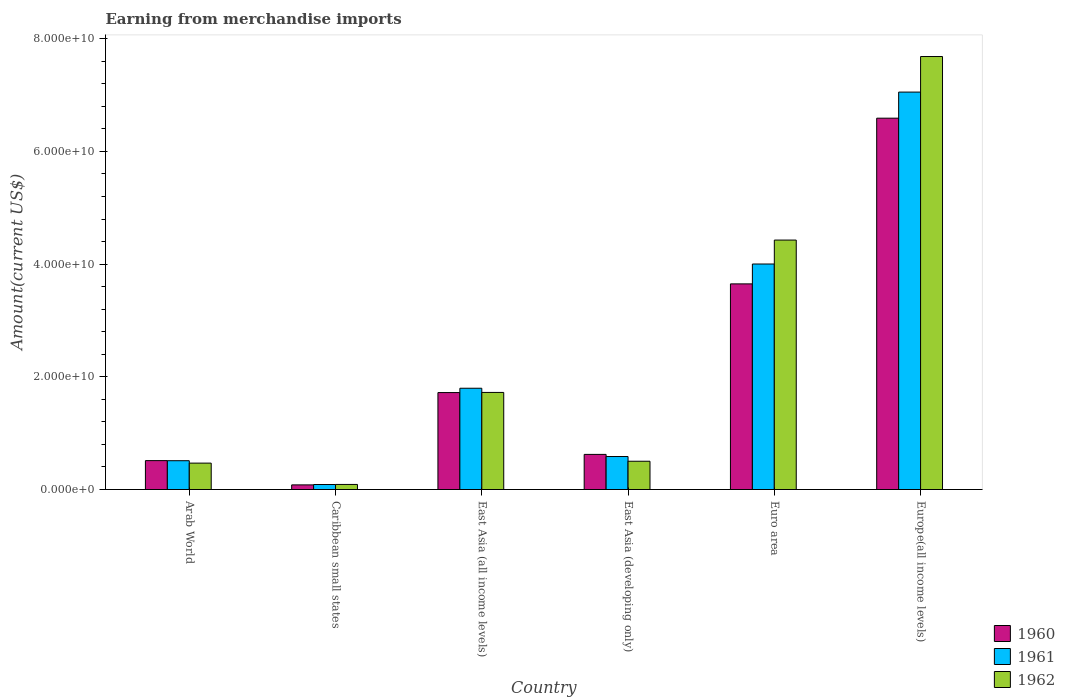How many groups of bars are there?
Offer a terse response. 6. Are the number of bars per tick equal to the number of legend labels?
Provide a short and direct response. Yes. How many bars are there on the 5th tick from the right?
Provide a short and direct response. 3. What is the label of the 1st group of bars from the left?
Offer a very short reply. Arab World. What is the amount earned from merchandise imports in 1961 in Arab World?
Offer a very short reply. 5.11e+09. Across all countries, what is the maximum amount earned from merchandise imports in 1962?
Provide a succinct answer. 7.68e+1. Across all countries, what is the minimum amount earned from merchandise imports in 1962?
Offer a terse response. 9.01e+08. In which country was the amount earned from merchandise imports in 1962 maximum?
Your response must be concise. Europe(all income levels). In which country was the amount earned from merchandise imports in 1960 minimum?
Provide a succinct answer. Caribbean small states. What is the total amount earned from merchandise imports in 1960 in the graph?
Make the answer very short. 1.32e+11. What is the difference between the amount earned from merchandise imports in 1962 in East Asia (developing only) and that in Euro area?
Your answer should be very brief. -3.93e+1. What is the difference between the amount earned from merchandise imports in 1962 in Arab World and the amount earned from merchandise imports in 1960 in East Asia (developing only)?
Your response must be concise. -1.55e+09. What is the average amount earned from merchandise imports in 1961 per country?
Provide a short and direct response. 2.34e+1. What is the difference between the amount earned from merchandise imports of/in 1961 and amount earned from merchandise imports of/in 1960 in East Asia (all income levels)?
Offer a very short reply. 7.70e+08. In how many countries, is the amount earned from merchandise imports in 1962 greater than 8000000000 US$?
Your answer should be very brief. 3. What is the ratio of the amount earned from merchandise imports in 1960 in Caribbean small states to that in East Asia (all income levels)?
Make the answer very short. 0.05. Is the amount earned from merchandise imports in 1961 in East Asia (all income levels) less than that in Europe(all income levels)?
Offer a terse response. Yes. Is the difference between the amount earned from merchandise imports in 1961 in East Asia (all income levels) and Europe(all income levels) greater than the difference between the amount earned from merchandise imports in 1960 in East Asia (all income levels) and Europe(all income levels)?
Keep it short and to the point. No. What is the difference between the highest and the second highest amount earned from merchandise imports in 1961?
Your answer should be very brief. 5.26e+1. What is the difference between the highest and the lowest amount earned from merchandise imports in 1961?
Your answer should be compact. 6.96e+1. In how many countries, is the amount earned from merchandise imports in 1962 greater than the average amount earned from merchandise imports in 1962 taken over all countries?
Provide a succinct answer. 2. Is the sum of the amount earned from merchandise imports in 1960 in East Asia (all income levels) and Europe(all income levels) greater than the maximum amount earned from merchandise imports in 1961 across all countries?
Offer a very short reply. Yes. What does the 2nd bar from the left in Arab World represents?
Your answer should be compact. 1961. What does the 2nd bar from the right in East Asia (all income levels) represents?
Your response must be concise. 1961. Is it the case that in every country, the sum of the amount earned from merchandise imports in 1961 and amount earned from merchandise imports in 1960 is greater than the amount earned from merchandise imports in 1962?
Provide a short and direct response. Yes. How many bars are there?
Offer a very short reply. 18. How many countries are there in the graph?
Ensure brevity in your answer.  6. Does the graph contain any zero values?
Give a very brief answer. No. Does the graph contain grids?
Offer a terse response. No. Where does the legend appear in the graph?
Offer a terse response. Bottom right. How many legend labels are there?
Offer a terse response. 3. What is the title of the graph?
Your answer should be very brief. Earning from merchandise imports. Does "1968" appear as one of the legend labels in the graph?
Your answer should be very brief. No. What is the label or title of the X-axis?
Make the answer very short. Country. What is the label or title of the Y-axis?
Offer a terse response. Amount(current US$). What is the Amount(current US$) in 1960 in Arab World?
Your answer should be very brief. 5.13e+09. What is the Amount(current US$) in 1961 in Arab World?
Keep it short and to the point. 5.11e+09. What is the Amount(current US$) in 1962 in Arab World?
Make the answer very short. 4.69e+09. What is the Amount(current US$) of 1960 in Caribbean small states?
Your response must be concise. 8.24e+08. What is the Amount(current US$) of 1961 in Caribbean small states?
Provide a short and direct response. 8.89e+08. What is the Amount(current US$) in 1962 in Caribbean small states?
Keep it short and to the point. 9.01e+08. What is the Amount(current US$) in 1960 in East Asia (all income levels)?
Your answer should be very brief. 1.72e+1. What is the Amount(current US$) in 1961 in East Asia (all income levels)?
Give a very brief answer. 1.80e+1. What is the Amount(current US$) of 1962 in East Asia (all income levels)?
Offer a terse response. 1.72e+1. What is the Amount(current US$) of 1960 in East Asia (developing only)?
Offer a terse response. 6.23e+09. What is the Amount(current US$) in 1961 in East Asia (developing only)?
Your answer should be compact. 5.86e+09. What is the Amount(current US$) in 1962 in East Asia (developing only)?
Ensure brevity in your answer.  5.02e+09. What is the Amount(current US$) of 1960 in Euro area?
Your answer should be very brief. 3.65e+1. What is the Amount(current US$) in 1961 in Euro area?
Provide a short and direct response. 4.00e+1. What is the Amount(current US$) in 1962 in Euro area?
Provide a short and direct response. 4.43e+1. What is the Amount(current US$) in 1960 in Europe(all income levels)?
Offer a very short reply. 6.59e+1. What is the Amount(current US$) of 1961 in Europe(all income levels)?
Ensure brevity in your answer.  7.05e+1. What is the Amount(current US$) in 1962 in Europe(all income levels)?
Your answer should be very brief. 7.68e+1. Across all countries, what is the maximum Amount(current US$) of 1960?
Give a very brief answer. 6.59e+1. Across all countries, what is the maximum Amount(current US$) in 1961?
Make the answer very short. 7.05e+1. Across all countries, what is the maximum Amount(current US$) in 1962?
Your answer should be compact. 7.68e+1. Across all countries, what is the minimum Amount(current US$) of 1960?
Your response must be concise. 8.24e+08. Across all countries, what is the minimum Amount(current US$) of 1961?
Provide a succinct answer. 8.89e+08. Across all countries, what is the minimum Amount(current US$) of 1962?
Provide a short and direct response. 9.01e+08. What is the total Amount(current US$) in 1960 in the graph?
Your answer should be very brief. 1.32e+11. What is the total Amount(current US$) in 1961 in the graph?
Offer a very short reply. 1.40e+11. What is the total Amount(current US$) of 1962 in the graph?
Provide a short and direct response. 1.49e+11. What is the difference between the Amount(current US$) of 1960 in Arab World and that in Caribbean small states?
Give a very brief answer. 4.31e+09. What is the difference between the Amount(current US$) in 1961 in Arab World and that in Caribbean small states?
Your answer should be very brief. 4.22e+09. What is the difference between the Amount(current US$) of 1962 in Arab World and that in Caribbean small states?
Your answer should be very brief. 3.78e+09. What is the difference between the Amount(current US$) in 1960 in Arab World and that in East Asia (all income levels)?
Keep it short and to the point. -1.21e+1. What is the difference between the Amount(current US$) of 1961 in Arab World and that in East Asia (all income levels)?
Offer a very short reply. -1.29e+1. What is the difference between the Amount(current US$) in 1962 in Arab World and that in East Asia (all income levels)?
Your answer should be very brief. -1.25e+1. What is the difference between the Amount(current US$) of 1960 in Arab World and that in East Asia (developing only)?
Provide a short and direct response. -1.10e+09. What is the difference between the Amount(current US$) in 1961 in Arab World and that in East Asia (developing only)?
Your answer should be very brief. -7.42e+08. What is the difference between the Amount(current US$) of 1962 in Arab World and that in East Asia (developing only)?
Offer a very short reply. -3.33e+08. What is the difference between the Amount(current US$) of 1960 in Arab World and that in Euro area?
Ensure brevity in your answer.  -3.14e+1. What is the difference between the Amount(current US$) of 1961 in Arab World and that in Euro area?
Provide a short and direct response. -3.49e+1. What is the difference between the Amount(current US$) in 1962 in Arab World and that in Euro area?
Give a very brief answer. -3.96e+1. What is the difference between the Amount(current US$) in 1960 in Arab World and that in Europe(all income levels)?
Ensure brevity in your answer.  -6.08e+1. What is the difference between the Amount(current US$) in 1961 in Arab World and that in Europe(all income levels)?
Provide a succinct answer. -6.54e+1. What is the difference between the Amount(current US$) in 1962 in Arab World and that in Europe(all income levels)?
Keep it short and to the point. -7.22e+1. What is the difference between the Amount(current US$) of 1960 in Caribbean small states and that in East Asia (all income levels)?
Offer a very short reply. -1.64e+1. What is the difference between the Amount(current US$) of 1961 in Caribbean small states and that in East Asia (all income levels)?
Offer a very short reply. -1.71e+1. What is the difference between the Amount(current US$) in 1962 in Caribbean small states and that in East Asia (all income levels)?
Keep it short and to the point. -1.63e+1. What is the difference between the Amount(current US$) in 1960 in Caribbean small states and that in East Asia (developing only)?
Ensure brevity in your answer.  -5.41e+09. What is the difference between the Amount(current US$) in 1961 in Caribbean small states and that in East Asia (developing only)?
Your response must be concise. -4.97e+09. What is the difference between the Amount(current US$) in 1962 in Caribbean small states and that in East Asia (developing only)?
Provide a succinct answer. -4.12e+09. What is the difference between the Amount(current US$) in 1960 in Caribbean small states and that in Euro area?
Provide a short and direct response. -3.57e+1. What is the difference between the Amount(current US$) of 1961 in Caribbean small states and that in Euro area?
Make the answer very short. -3.91e+1. What is the difference between the Amount(current US$) of 1962 in Caribbean small states and that in Euro area?
Give a very brief answer. -4.34e+1. What is the difference between the Amount(current US$) of 1960 in Caribbean small states and that in Europe(all income levels)?
Make the answer very short. -6.51e+1. What is the difference between the Amount(current US$) in 1961 in Caribbean small states and that in Europe(all income levels)?
Ensure brevity in your answer.  -6.96e+1. What is the difference between the Amount(current US$) in 1962 in Caribbean small states and that in Europe(all income levels)?
Provide a succinct answer. -7.59e+1. What is the difference between the Amount(current US$) of 1960 in East Asia (all income levels) and that in East Asia (developing only)?
Keep it short and to the point. 1.10e+1. What is the difference between the Amount(current US$) of 1961 in East Asia (all income levels) and that in East Asia (developing only)?
Offer a very short reply. 1.21e+1. What is the difference between the Amount(current US$) in 1962 in East Asia (all income levels) and that in East Asia (developing only)?
Provide a short and direct response. 1.22e+1. What is the difference between the Amount(current US$) in 1960 in East Asia (all income levels) and that in Euro area?
Provide a short and direct response. -1.93e+1. What is the difference between the Amount(current US$) in 1961 in East Asia (all income levels) and that in Euro area?
Provide a short and direct response. -2.20e+1. What is the difference between the Amount(current US$) of 1962 in East Asia (all income levels) and that in Euro area?
Make the answer very short. -2.70e+1. What is the difference between the Amount(current US$) in 1960 in East Asia (all income levels) and that in Europe(all income levels)?
Provide a short and direct response. -4.87e+1. What is the difference between the Amount(current US$) of 1961 in East Asia (all income levels) and that in Europe(all income levels)?
Your answer should be compact. -5.26e+1. What is the difference between the Amount(current US$) in 1962 in East Asia (all income levels) and that in Europe(all income levels)?
Your response must be concise. -5.96e+1. What is the difference between the Amount(current US$) in 1960 in East Asia (developing only) and that in Euro area?
Your answer should be compact. -3.03e+1. What is the difference between the Amount(current US$) in 1961 in East Asia (developing only) and that in Euro area?
Provide a short and direct response. -3.42e+1. What is the difference between the Amount(current US$) in 1962 in East Asia (developing only) and that in Euro area?
Provide a succinct answer. -3.93e+1. What is the difference between the Amount(current US$) in 1960 in East Asia (developing only) and that in Europe(all income levels)?
Provide a short and direct response. -5.97e+1. What is the difference between the Amount(current US$) of 1961 in East Asia (developing only) and that in Europe(all income levels)?
Your response must be concise. -6.47e+1. What is the difference between the Amount(current US$) of 1962 in East Asia (developing only) and that in Europe(all income levels)?
Provide a succinct answer. -7.18e+1. What is the difference between the Amount(current US$) of 1960 in Euro area and that in Europe(all income levels)?
Keep it short and to the point. -2.94e+1. What is the difference between the Amount(current US$) in 1961 in Euro area and that in Europe(all income levels)?
Provide a short and direct response. -3.05e+1. What is the difference between the Amount(current US$) in 1962 in Euro area and that in Europe(all income levels)?
Provide a short and direct response. -3.26e+1. What is the difference between the Amount(current US$) in 1960 in Arab World and the Amount(current US$) in 1961 in Caribbean small states?
Offer a terse response. 4.24e+09. What is the difference between the Amount(current US$) in 1960 in Arab World and the Amount(current US$) in 1962 in Caribbean small states?
Keep it short and to the point. 4.23e+09. What is the difference between the Amount(current US$) of 1961 in Arab World and the Amount(current US$) of 1962 in Caribbean small states?
Your answer should be compact. 4.21e+09. What is the difference between the Amount(current US$) in 1960 in Arab World and the Amount(current US$) in 1961 in East Asia (all income levels)?
Offer a very short reply. -1.28e+1. What is the difference between the Amount(current US$) of 1960 in Arab World and the Amount(current US$) of 1962 in East Asia (all income levels)?
Ensure brevity in your answer.  -1.21e+1. What is the difference between the Amount(current US$) in 1961 in Arab World and the Amount(current US$) in 1962 in East Asia (all income levels)?
Your answer should be very brief. -1.21e+1. What is the difference between the Amount(current US$) in 1960 in Arab World and the Amount(current US$) in 1961 in East Asia (developing only)?
Offer a very short reply. -7.25e+08. What is the difference between the Amount(current US$) in 1960 in Arab World and the Amount(current US$) in 1962 in East Asia (developing only)?
Ensure brevity in your answer.  1.13e+08. What is the difference between the Amount(current US$) of 1961 in Arab World and the Amount(current US$) of 1962 in East Asia (developing only)?
Provide a short and direct response. 9.57e+07. What is the difference between the Amount(current US$) in 1960 in Arab World and the Amount(current US$) in 1961 in Euro area?
Provide a short and direct response. -3.49e+1. What is the difference between the Amount(current US$) of 1960 in Arab World and the Amount(current US$) of 1962 in Euro area?
Offer a very short reply. -3.91e+1. What is the difference between the Amount(current US$) of 1961 in Arab World and the Amount(current US$) of 1962 in Euro area?
Your answer should be very brief. -3.92e+1. What is the difference between the Amount(current US$) in 1960 in Arab World and the Amount(current US$) in 1961 in Europe(all income levels)?
Your response must be concise. -6.54e+1. What is the difference between the Amount(current US$) of 1960 in Arab World and the Amount(current US$) of 1962 in Europe(all income levels)?
Give a very brief answer. -7.17e+1. What is the difference between the Amount(current US$) in 1961 in Arab World and the Amount(current US$) in 1962 in Europe(all income levels)?
Offer a terse response. -7.17e+1. What is the difference between the Amount(current US$) in 1960 in Caribbean small states and the Amount(current US$) in 1961 in East Asia (all income levels)?
Your answer should be very brief. -1.72e+1. What is the difference between the Amount(current US$) of 1960 in Caribbean small states and the Amount(current US$) of 1962 in East Asia (all income levels)?
Your response must be concise. -1.64e+1. What is the difference between the Amount(current US$) of 1961 in Caribbean small states and the Amount(current US$) of 1962 in East Asia (all income levels)?
Ensure brevity in your answer.  -1.63e+1. What is the difference between the Amount(current US$) of 1960 in Caribbean small states and the Amount(current US$) of 1961 in East Asia (developing only)?
Provide a succinct answer. -5.03e+09. What is the difference between the Amount(current US$) in 1960 in Caribbean small states and the Amount(current US$) in 1962 in East Asia (developing only)?
Ensure brevity in your answer.  -4.19e+09. What is the difference between the Amount(current US$) in 1961 in Caribbean small states and the Amount(current US$) in 1962 in East Asia (developing only)?
Offer a terse response. -4.13e+09. What is the difference between the Amount(current US$) in 1960 in Caribbean small states and the Amount(current US$) in 1961 in Euro area?
Give a very brief answer. -3.92e+1. What is the difference between the Amount(current US$) in 1960 in Caribbean small states and the Amount(current US$) in 1962 in Euro area?
Give a very brief answer. -4.34e+1. What is the difference between the Amount(current US$) in 1961 in Caribbean small states and the Amount(current US$) in 1962 in Euro area?
Your answer should be very brief. -4.34e+1. What is the difference between the Amount(current US$) in 1960 in Caribbean small states and the Amount(current US$) in 1961 in Europe(all income levels)?
Make the answer very short. -6.97e+1. What is the difference between the Amount(current US$) in 1960 in Caribbean small states and the Amount(current US$) in 1962 in Europe(all income levels)?
Your response must be concise. -7.60e+1. What is the difference between the Amount(current US$) of 1961 in Caribbean small states and the Amount(current US$) of 1962 in Europe(all income levels)?
Your answer should be very brief. -7.60e+1. What is the difference between the Amount(current US$) in 1960 in East Asia (all income levels) and the Amount(current US$) in 1961 in East Asia (developing only)?
Your response must be concise. 1.13e+1. What is the difference between the Amount(current US$) in 1960 in East Asia (all income levels) and the Amount(current US$) in 1962 in East Asia (developing only)?
Your answer should be very brief. 1.22e+1. What is the difference between the Amount(current US$) of 1961 in East Asia (all income levels) and the Amount(current US$) of 1962 in East Asia (developing only)?
Provide a short and direct response. 1.30e+1. What is the difference between the Amount(current US$) in 1960 in East Asia (all income levels) and the Amount(current US$) in 1961 in Euro area?
Ensure brevity in your answer.  -2.28e+1. What is the difference between the Amount(current US$) in 1960 in East Asia (all income levels) and the Amount(current US$) in 1962 in Euro area?
Provide a short and direct response. -2.71e+1. What is the difference between the Amount(current US$) of 1961 in East Asia (all income levels) and the Amount(current US$) of 1962 in Euro area?
Give a very brief answer. -2.63e+1. What is the difference between the Amount(current US$) of 1960 in East Asia (all income levels) and the Amount(current US$) of 1961 in Europe(all income levels)?
Give a very brief answer. -5.33e+1. What is the difference between the Amount(current US$) in 1960 in East Asia (all income levels) and the Amount(current US$) in 1962 in Europe(all income levels)?
Your answer should be compact. -5.96e+1. What is the difference between the Amount(current US$) of 1961 in East Asia (all income levels) and the Amount(current US$) of 1962 in Europe(all income levels)?
Your response must be concise. -5.89e+1. What is the difference between the Amount(current US$) in 1960 in East Asia (developing only) and the Amount(current US$) in 1961 in Euro area?
Your answer should be compact. -3.38e+1. What is the difference between the Amount(current US$) in 1960 in East Asia (developing only) and the Amount(current US$) in 1962 in Euro area?
Your answer should be very brief. -3.80e+1. What is the difference between the Amount(current US$) of 1961 in East Asia (developing only) and the Amount(current US$) of 1962 in Euro area?
Offer a very short reply. -3.84e+1. What is the difference between the Amount(current US$) of 1960 in East Asia (developing only) and the Amount(current US$) of 1961 in Europe(all income levels)?
Your response must be concise. -6.43e+1. What is the difference between the Amount(current US$) in 1960 in East Asia (developing only) and the Amount(current US$) in 1962 in Europe(all income levels)?
Give a very brief answer. -7.06e+1. What is the difference between the Amount(current US$) in 1961 in East Asia (developing only) and the Amount(current US$) in 1962 in Europe(all income levels)?
Keep it short and to the point. -7.10e+1. What is the difference between the Amount(current US$) of 1960 in Euro area and the Amount(current US$) of 1961 in Europe(all income levels)?
Keep it short and to the point. -3.40e+1. What is the difference between the Amount(current US$) of 1960 in Euro area and the Amount(current US$) of 1962 in Europe(all income levels)?
Your response must be concise. -4.04e+1. What is the difference between the Amount(current US$) in 1961 in Euro area and the Amount(current US$) in 1962 in Europe(all income levels)?
Your answer should be very brief. -3.68e+1. What is the average Amount(current US$) of 1960 per country?
Ensure brevity in your answer.  2.20e+1. What is the average Amount(current US$) in 1961 per country?
Keep it short and to the point. 2.34e+1. What is the average Amount(current US$) in 1962 per country?
Your answer should be very brief. 2.48e+1. What is the difference between the Amount(current US$) in 1960 and Amount(current US$) in 1961 in Arab World?
Your response must be concise. 1.72e+07. What is the difference between the Amount(current US$) in 1960 and Amount(current US$) in 1962 in Arab World?
Make the answer very short. 4.46e+08. What is the difference between the Amount(current US$) in 1961 and Amount(current US$) in 1962 in Arab World?
Provide a succinct answer. 4.28e+08. What is the difference between the Amount(current US$) in 1960 and Amount(current US$) in 1961 in Caribbean small states?
Ensure brevity in your answer.  -6.47e+07. What is the difference between the Amount(current US$) of 1960 and Amount(current US$) of 1962 in Caribbean small states?
Provide a succinct answer. -7.66e+07. What is the difference between the Amount(current US$) of 1961 and Amount(current US$) of 1962 in Caribbean small states?
Give a very brief answer. -1.19e+07. What is the difference between the Amount(current US$) in 1960 and Amount(current US$) in 1961 in East Asia (all income levels)?
Keep it short and to the point. -7.70e+08. What is the difference between the Amount(current US$) in 1960 and Amount(current US$) in 1962 in East Asia (all income levels)?
Your answer should be very brief. -2.54e+07. What is the difference between the Amount(current US$) of 1961 and Amount(current US$) of 1962 in East Asia (all income levels)?
Give a very brief answer. 7.44e+08. What is the difference between the Amount(current US$) in 1960 and Amount(current US$) in 1961 in East Asia (developing only)?
Your response must be concise. 3.78e+08. What is the difference between the Amount(current US$) in 1960 and Amount(current US$) in 1962 in East Asia (developing only)?
Keep it short and to the point. 1.22e+09. What is the difference between the Amount(current US$) of 1961 and Amount(current US$) of 1962 in East Asia (developing only)?
Give a very brief answer. 8.38e+08. What is the difference between the Amount(current US$) of 1960 and Amount(current US$) of 1961 in Euro area?
Offer a terse response. -3.53e+09. What is the difference between the Amount(current US$) of 1960 and Amount(current US$) of 1962 in Euro area?
Offer a very short reply. -7.78e+09. What is the difference between the Amount(current US$) of 1961 and Amount(current US$) of 1962 in Euro area?
Your answer should be very brief. -4.25e+09. What is the difference between the Amount(current US$) of 1960 and Amount(current US$) of 1961 in Europe(all income levels)?
Your answer should be very brief. -4.63e+09. What is the difference between the Amount(current US$) in 1960 and Amount(current US$) in 1962 in Europe(all income levels)?
Give a very brief answer. -1.09e+1. What is the difference between the Amount(current US$) in 1961 and Amount(current US$) in 1962 in Europe(all income levels)?
Your response must be concise. -6.31e+09. What is the ratio of the Amount(current US$) in 1960 in Arab World to that in Caribbean small states?
Make the answer very short. 6.23. What is the ratio of the Amount(current US$) in 1961 in Arab World to that in Caribbean small states?
Your response must be concise. 5.75. What is the ratio of the Amount(current US$) of 1962 in Arab World to that in Caribbean small states?
Make the answer very short. 5.2. What is the ratio of the Amount(current US$) in 1960 in Arab World to that in East Asia (all income levels)?
Provide a short and direct response. 0.3. What is the ratio of the Amount(current US$) of 1961 in Arab World to that in East Asia (all income levels)?
Provide a short and direct response. 0.28. What is the ratio of the Amount(current US$) of 1962 in Arab World to that in East Asia (all income levels)?
Your answer should be very brief. 0.27. What is the ratio of the Amount(current US$) in 1960 in Arab World to that in East Asia (developing only)?
Keep it short and to the point. 0.82. What is the ratio of the Amount(current US$) in 1961 in Arab World to that in East Asia (developing only)?
Offer a terse response. 0.87. What is the ratio of the Amount(current US$) in 1962 in Arab World to that in East Asia (developing only)?
Provide a short and direct response. 0.93. What is the ratio of the Amount(current US$) of 1960 in Arab World to that in Euro area?
Provide a succinct answer. 0.14. What is the ratio of the Amount(current US$) of 1961 in Arab World to that in Euro area?
Offer a very short reply. 0.13. What is the ratio of the Amount(current US$) in 1962 in Arab World to that in Euro area?
Make the answer very short. 0.11. What is the ratio of the Amount(current US$) in 1960 in Arab World to that in Europe(all income levels)?
Provide a succinct answer. 0.08. What is the ratio of the Amount(current US$) of 1961 in Arab World to that in Europe(all income levels)?
Your answer should be compact. 0.07. What is the ratio of the Amount(current US$) in 1962 in Arab World to that in Europe(all income levels)?
Ensure brevity in your answer.  0.06. What is the ratio of the Amount(current US$) in 1960 in Caribbean small states to that in East Asia (all income levels)?
Make the answer very short. 0.05. What is the ratio of the Amount(current US$) in 1961 in Caribbean small states to that in East Asia (all income levels)?
Your response must be concise. 0.05. What is the ratio of the Amount(current US$) in 1962 in Caribbean small states to that in East Asia (all income levels)?
Your response must be concise. 0.05. What is the ratio of the Amount(current US$) of 1960 in Caribbean small states to that in East Asia (developing only)?
Your answer should be compact. 0.13. What is the ratio of the Amount(current US$) in 1961 in Caribbean small states to that in East Asia (developing only)?
Ensure brevity in your answer.  0.15. What is the ratio of the Amount(current US$) of 1962 in Caribbean small states to that in East Asia (developing only)?
Give a very brief answer. 0.18. What is the ratio of the Amount(current US$) in 1960 in Caribbean small states to that in Euro area?
Offer a very short reply. 0.02. What is the ratio of the Amount(current US$) of 1961 in Caribbean small states to that in Euro area?
Provide a short and direct response. 0.02. What is the ratio of the Amount(current US$) of 1962 in Caribbean small states to that in Euro area?
Your answer should be compact. 0.02. What is the ratio of the Amount(current US$) in 1960 in Caribbean small states to that in Europe(all income levels)?
Give a very brief answer. 0.01. What is the ratio of the Amount(current US$) in 1961 in Caribbean small states to that in Europe(all income levels)?
Offer a very short reply. 0.01. What is the ratio of the Amount(current US$) in 1962 in Caribbean small states to that in Europe(all income levels)?
Ensure brevity in your answer.  0.01. What is the ratio of the Amount(current US$) in 1960 in East Asia (all income levels) to that in East Asia (developing only)?
Offer a terse response. 2.76. What is the ratio of the Amount(current US$) in 1961 in East Asia (all income levels) to that in East Asia (developing only)?
Give a very brief answer. 3.07. What is the ratio of the Amount(current US$) of 1962 in East Asia (all income levels) to that in East Asia (developing only)?
Provide a succinct answer. 3.43. What is the ratio of the Amount(current US$) in 1960 in East Asia (all income levels) to that in Euro area?
Offer a very short reply. 0.47. What is the ratio of the Amount(current US$) of 1961 in East Asia (all income levels) to that in Euro area?
Provide a short and direct response. 0.45. What is the ratio of the Amount(current US$) of 1962 in East Asia (all income levels) to that in Euro area?
Ensure brevity in your answer.  0.39. What is the ratio of the Amount(current US$) in 1960 in East Asia (all income levels) to that in Europe(all income levels)?
Give a very brief answer. 0.26. What is the ratio of the Amount(current US$) of 1961 in East Asia (all income levels) to that in Europe(all income levels)?
Your answer should be very brief. 0.25. What is the ratio of the Amount(current US$) in 1962 in East Asia (all income levels) to that in Europe(all income levels)?
Make the answer very short. 0.22. What is the ratio of the Amount(current US$) of 1960 in East Asia (developing only) to that in Euro area?
Provide a succinct answer. 0.17. What is the ratio of the Amount(current US$) in 1961 in East Asia (developing only) to that in Euro area?
Offer a very short reply. 0.15. What is the ratio of the Amount(current US$) of 1962 in East Asia (developing only) to that in Euro area?
Your answer should be very brief. 0.11. What is the ratio of the Amount(current US$) in 1960 in East Asia (developing only) to that in Europe(all income levels)?
Ensure brevity in your answer.  0.09. What is the ratio of the Amount(current US$) of 1961 in East Asia (developing only) to that in Europe(all income levels)?
Your answer should be compact. 0.08. What is the ratio of the Amount(current US$) of 1962 in East Asia (developing only) to that in Europe(all income levels)?
Make the answer very short. 0.07. What is the ratio of the Amount(current US$) of 1960 in Euro area to that in Europe(all income levels)?
Provide a succinct answer. 0.55. What is the ratio of the Amount(current US$) in 1961 in Euro area to that in Europe(all income levels)?
Offer a very short reply. 0.57. What is the ratio of the Amount(current US$) of 1962 in Euro area to that in Europe(all income levels)?
Make the answer very short. 0.58. What is the difference between the highest and the second highest Amount(current US$) of 1960?
Your response must be concise. 2.94e+1. What is the difference between the highest and the second highest Amount(current US$) in 1961?
Your response must be concise. 3.05e+1. What is the difference between the highest and the second highest Amount(current US$) of 1962?
Give a very brief answer. 3.26e+1. What is the difference between the highest and the lowest Amount(current US$) of 1960?
Provide a short and direct response. 6.51e+1. What is the difference between the highest and the lowest Amount(current US$) of 1961?
Keep it short and to the point. 6.96e+1. What is the difference between the highest and the lowest Amount(current US$) in 1962?
Make the answer very short. 7.59e+1. 